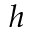Convert formula to latex. <formula><loc_0><loc_0><loc_500><loc_500>h</formula> 